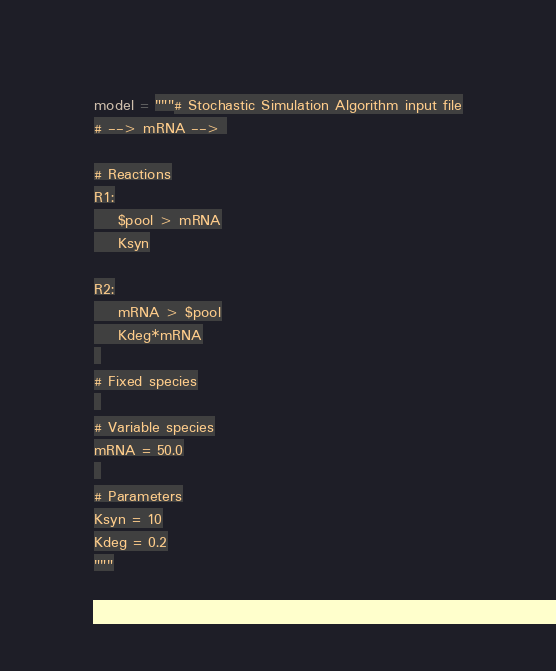<code> <loc_0><loc_0><loc_500><loc_500><_Python_>model = """# Stochastic Simulation Algorithm input file
# --> mRNA --> 

# Reactions
R1:
    $pool > mRNA
    Ksyn

R2:
    mRNA > $pool
    Kdeg*mRNA
 
# Fixed species
 
# Variable species
mRNA = 50.0
 
# Parameters
Ksyn = 10
Kdeg = 0.2
"""
</code> 